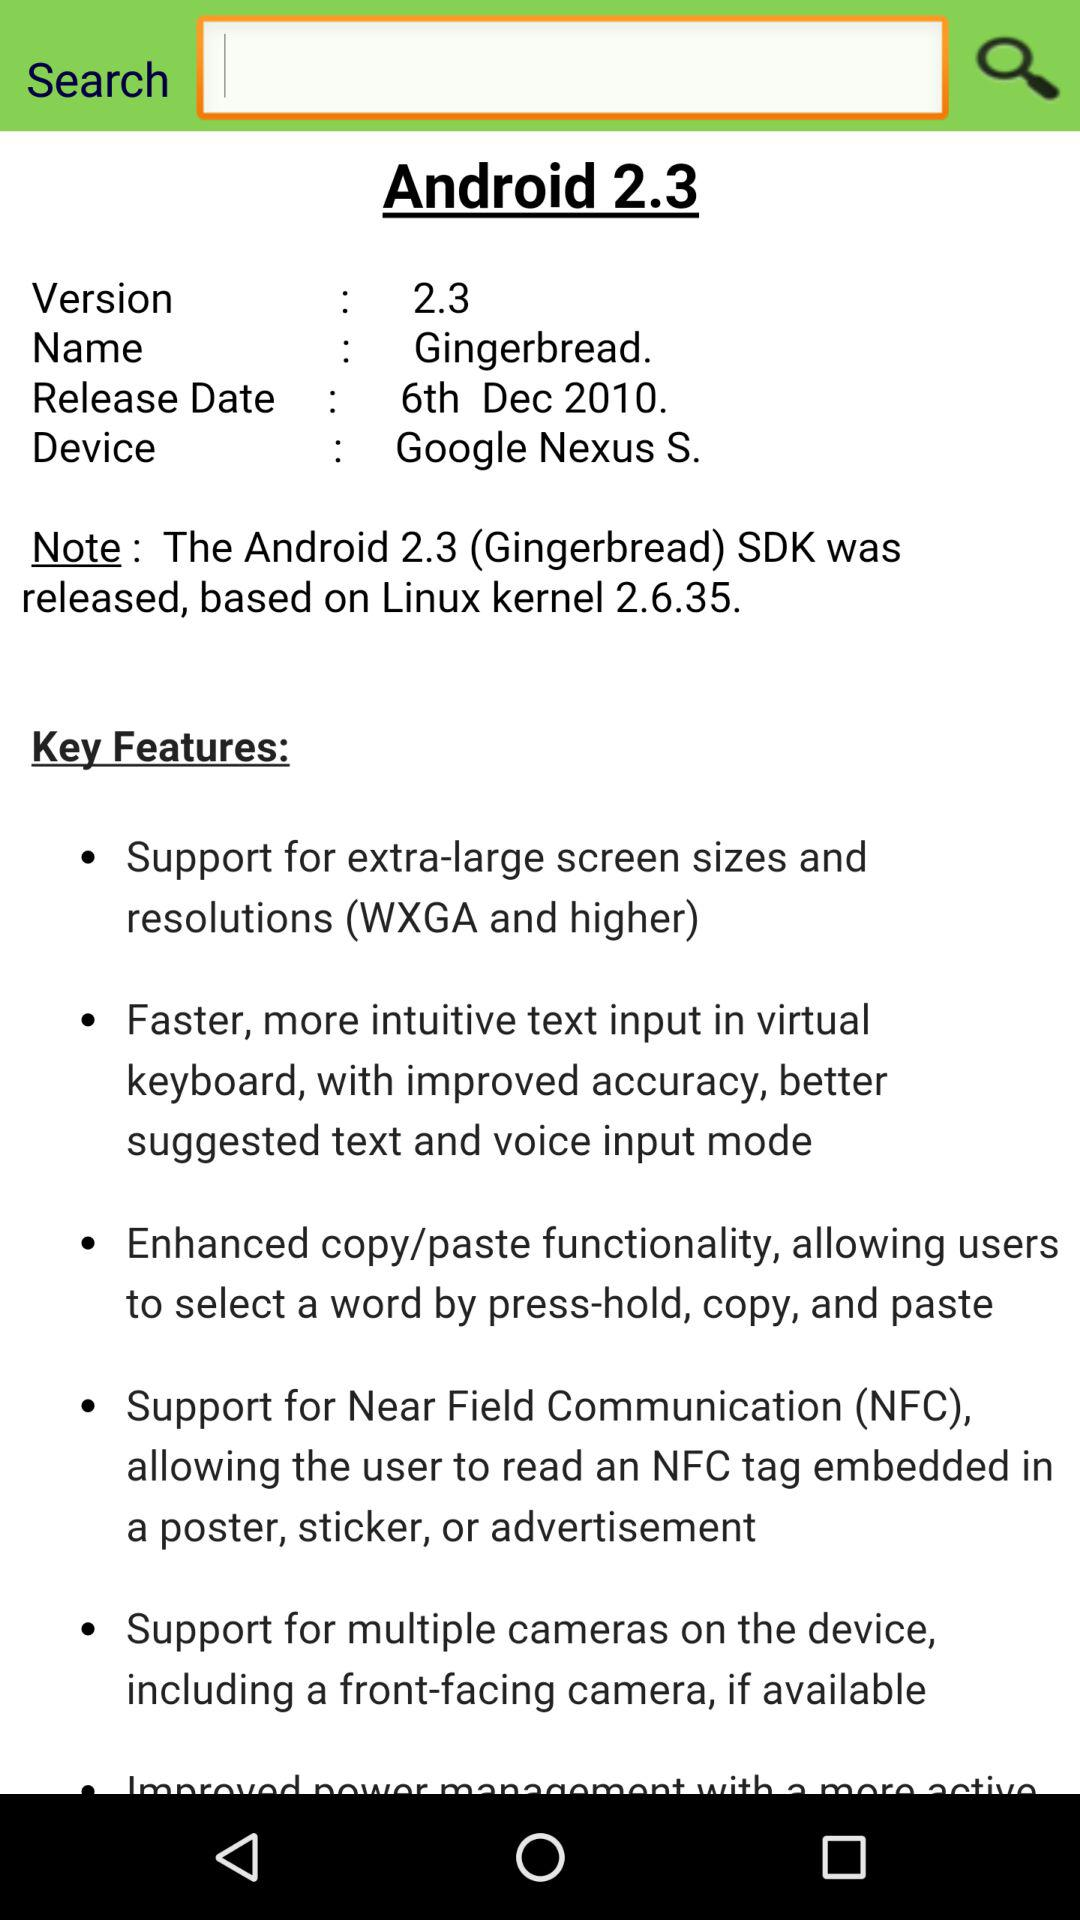What is the name of the Android? The name of the Android is Gingerbread. 